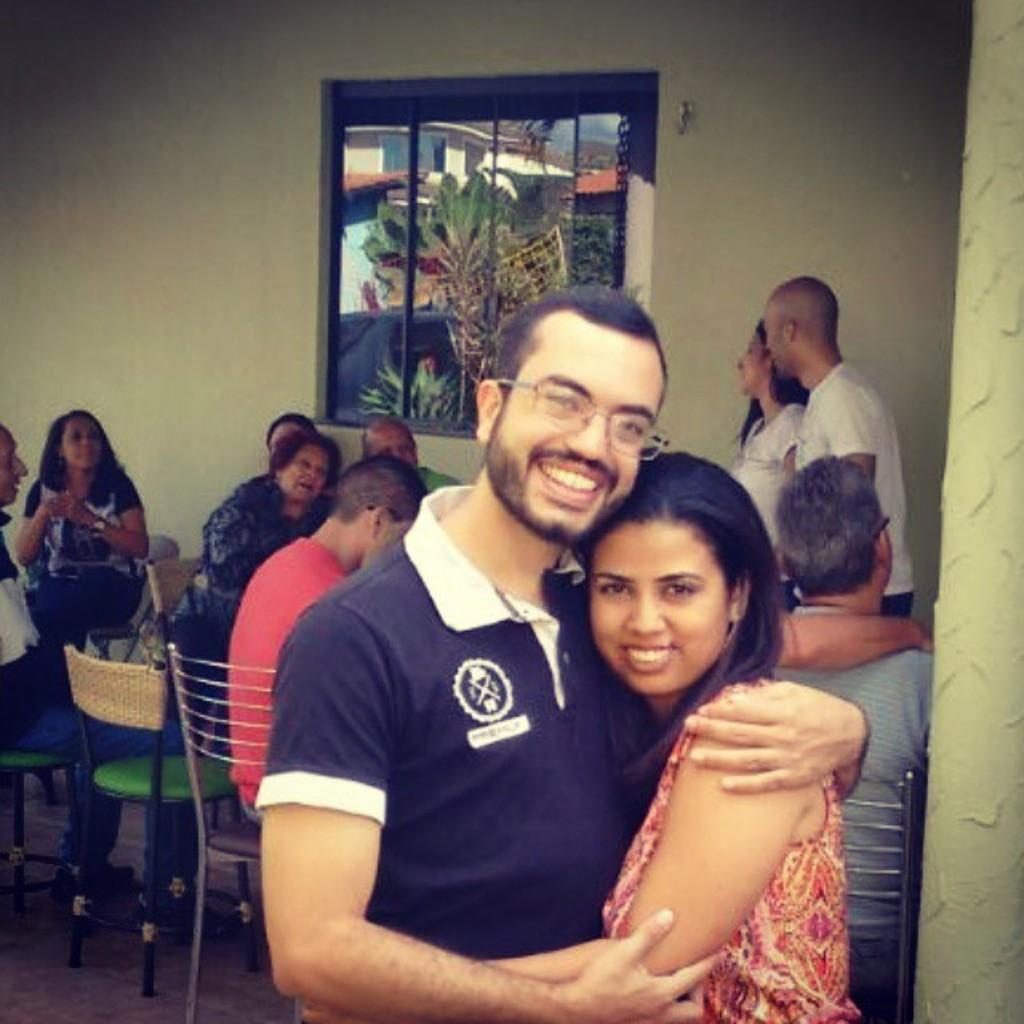What are the two main subjects in the image doing? The man and the lady are standing and smiling in the center of the image. What can be observed about the people in the background? There are people sitting in the background. What type of furniture is present in the image? There are chairs in the image. What architectural features can be seen in the image? There is a window and a wall in the image. What type of creature is causing the people in the image to be angry? There is no creature present in the image, and no one appears to be angry. Can you see any steam coming from the window in the image? There is no steam visible in the image; only the window and the wall are present. 